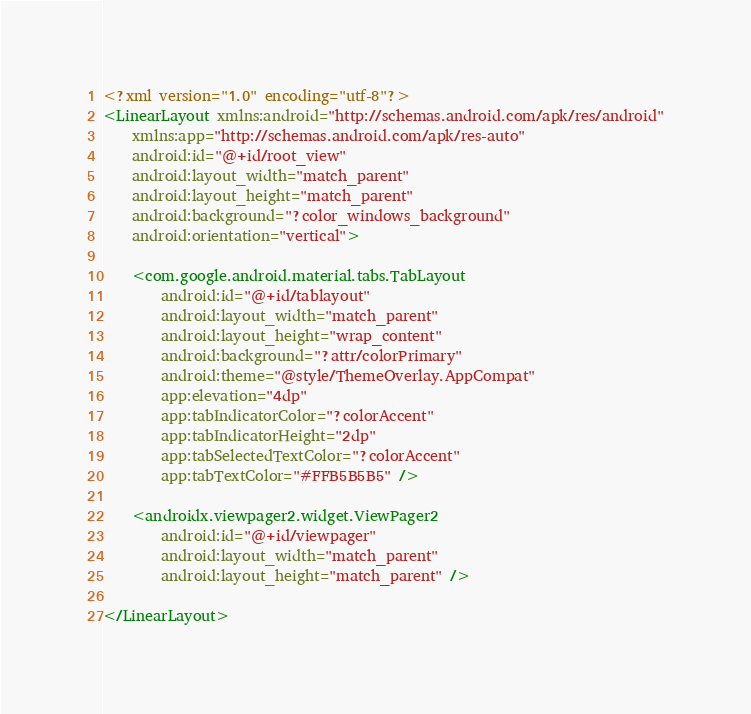<code> <loc_0><loc_0><loc_500><loc_500><_XML_><?xml version="1.0" encoding="utf-8"?>
<LinearLayout xmlns:android="http://schemas.android.com/apk/res/android"
    xmlns:app="http://schemas.android.com/apk/res-auto"
    android:id="@+id/root_view"
    android:layout_width="match_parent"
    android:layout_height="match_parent"
    android:background="?color_windows_background"
    android:orientation="vertical">

    <com.google.android.material.tabs.TabLayout
        android:id="@+id/tablayout"
        android:layout_width="match_parent"
        android:layout_height="wrap_content"
        android:background="?attr/colorPrimary"
        android:theme="@style/ThemeOverlay.AppCompat"
        app:elevation="4dp"
        app:tabIndicatorColor="?colorAccent"
        app:tabIndicatorHeight="2dp"
        app:tabSelectedTextColor="?colorAccent"
        app:tabTextColor="#FFB5B5B5" />

    <androidx.viewpager2.widget.ViewPager2
        android:id="@+id/viewpager"
        android:layout_width="match_parent"
        android:layout_height="match_parent" />

</LinearLayout></code> 